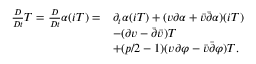<formula> <loc_0><loc_0><loc_500><loc_500>\begin{array} { r l } { \frac { D } { D t } T = \frac { D } { D t } \alpha ( i T ) = } & { \partial _ { t } \alpha ( i T ) + ( v \partial \alpha + \bar { v } \bar { \partial } \alpha ) ( i T ) } \\ & { - ( \partial v - \bar { \partial } \bar { v } ) T } \\ & { + ( p / 2 - 1 ) ( v \partial \varphi - \bar { v } \bar { \partial } \varphi ) T . } \end{array}</formula> 